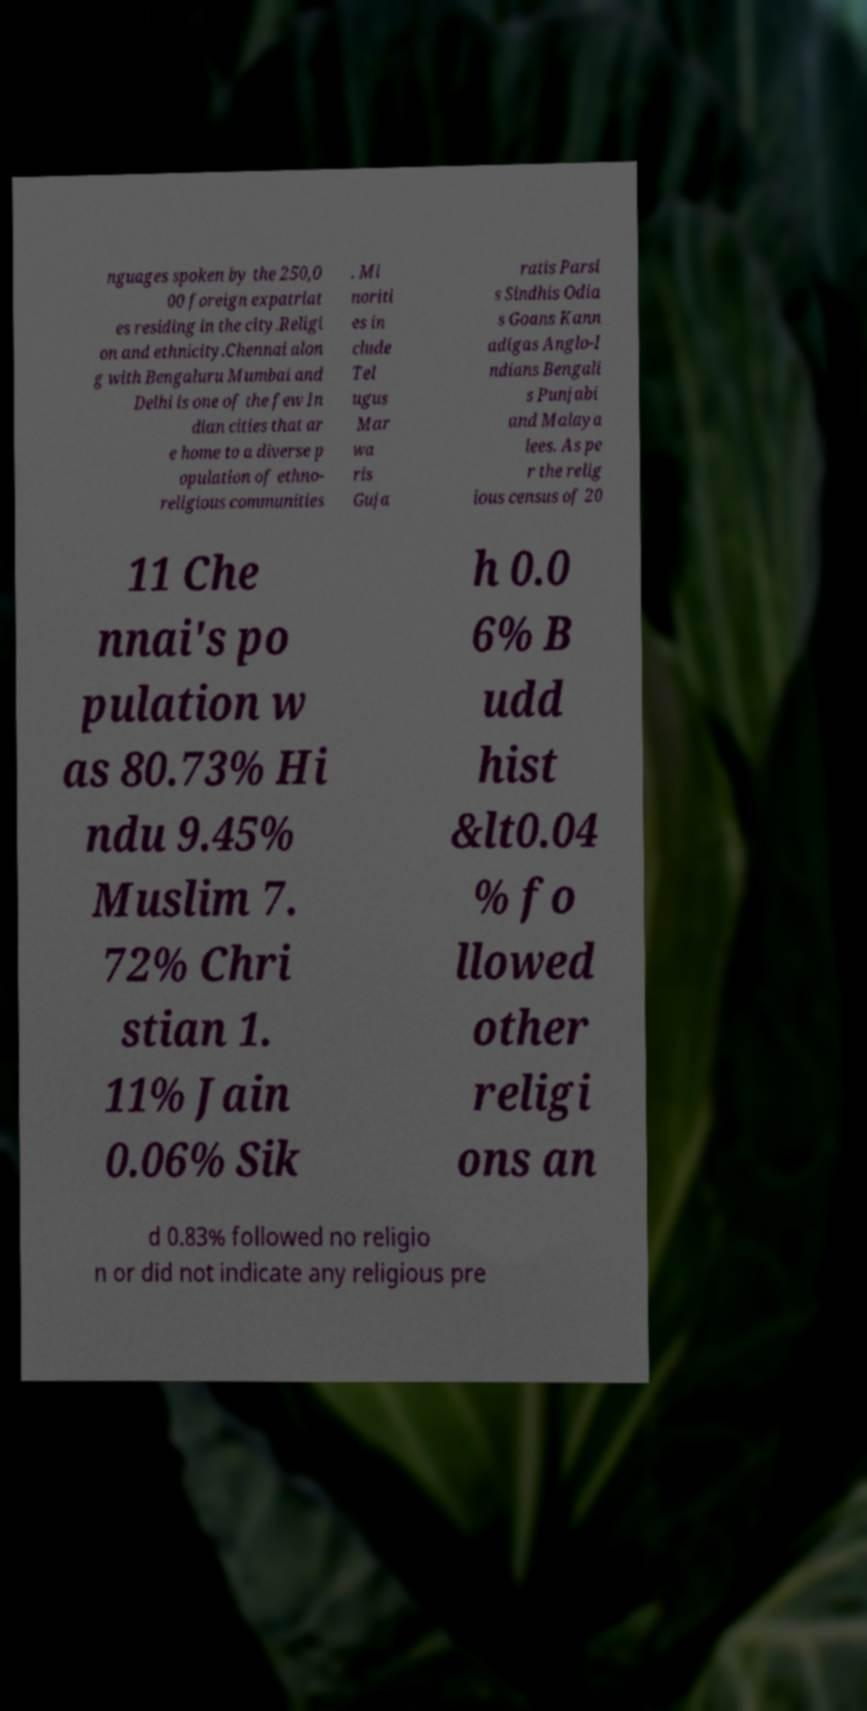Please read and relay the text visible in this image. What does it say? nguages spoken by the 250,0 00 foreign expatriat es residing in the city.Religi on and ethnicity.Chennai alon g with Bengaluru Mumbai and Delhi is one of the few In dian cities that ar e home to a diverse p opulation of ethno- religious communities . Mi noriti es in clude Tel ugus Mar wa ris Guja ratis Parsi s Sindhis Odia s Goans Kann adigas Anglo-I ndians Bengali s Punjabi and Malaya lees. As pe r the relig ious census of 20 11 Che nnai's po pulation w as 80.73% Hi ndu 9.45% Muslim 7. 72% Chri stian 1. 11% Jain 0.06% Sik h 0.0 6% B udd hist &lt0.04 % fo llowed other religi ons an d 0.83% followed no religio n or did not indicate any religious pre 